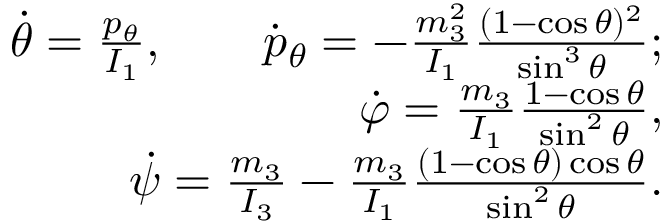<formula> <loc_0><loc_0><loc_500><loc_500>\begin{array} { r } { \dot { \theta } = \frac { p _ { \theta } } { I _ { 1 } } , \quad \dot { p } _ { \theta } = - \frac { m _ { 3 } ^ { 2 } } { I _ { 1 } } \frac { ( 1 - \cos \theta ) ^ { 2 } } { \sin ^ { 3 } \theta } ; } \\ { \dot { \varphi } = \frac { m _ { 3 } } { I _ { 1 } } \frac { 1 - \cos \theta } { \sin ^ { 2 } \theta } , } \\ { \dot { \psi } = \frac { m _ { 3 } } { I _ { 3 } } - \frac { m _ { 3 } } { I _ { 1 } } \frac { ( 1 - \cos \theta ) \cos \theta } { \sin ^ { 2 } \theta } . } \end{array}</formula> 